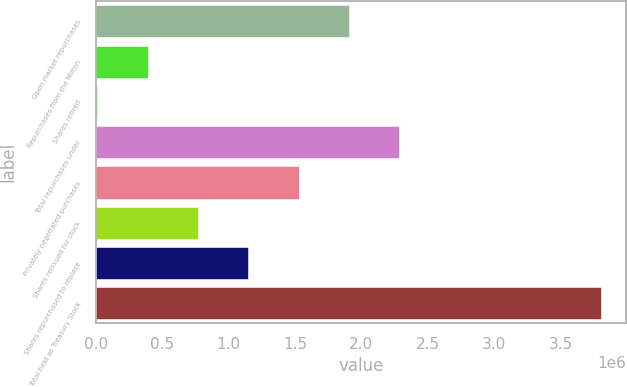Convert chart to OTSL. <chart><loc_0><loc_0><loc_500><loc_500><bar_chart><fcel>Open market repurchases<fcel>Repurchases from the Milton<fcel>Shares retired<fcel>Total repurchases under<fcel>Privately negotiated purchases<fcel>Shares reissued for stock<fcel>Shares repurchased to replace<fcel>Total held as Treasury Stock<nl><fcel>1.90738e+06<fcel>391733<fcel>12820<fcel>2.2863e+06<fcel>1.52847e+06<fcel>770645<fcel>1.14956e+06<fcel>3.80195e+06<nl></chart> 